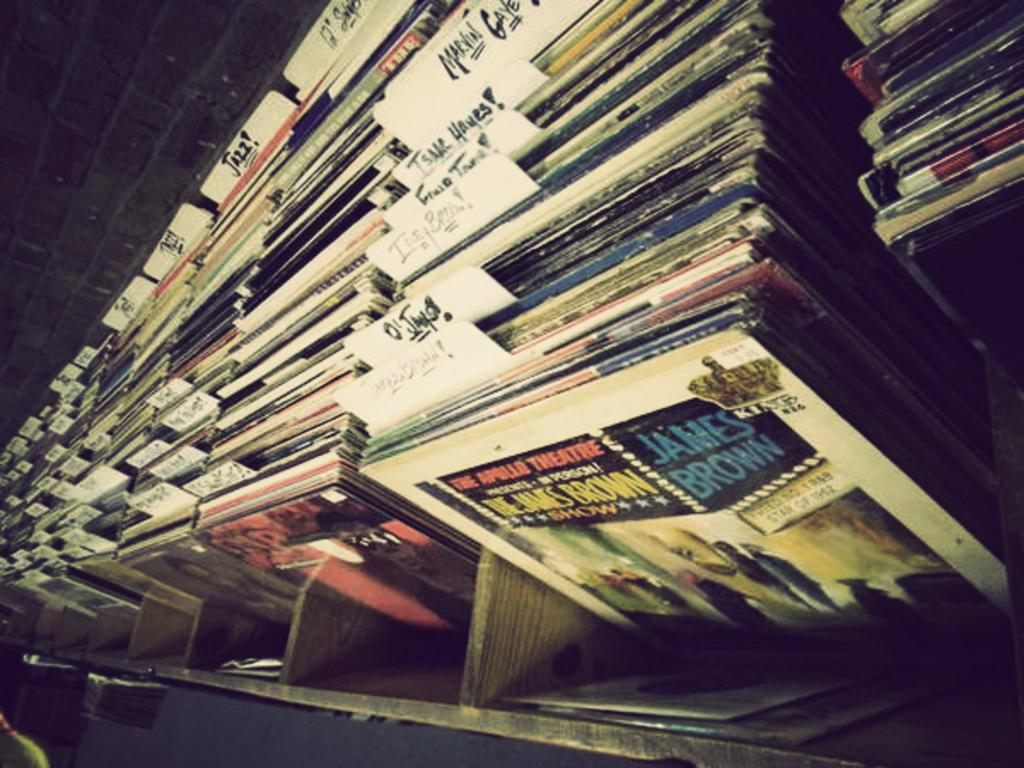<image>
Write a terse but informative summary of the picture. the name James Brown is on an album 